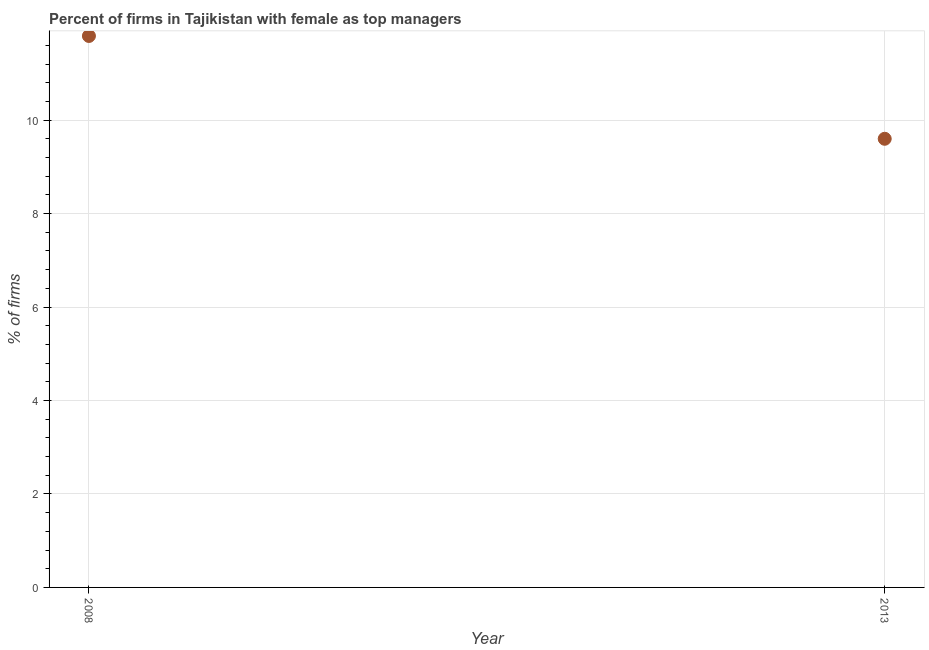Across all years, what is the minimum percentage of firms with female as top manager?
Your answer should be very brief. 9.6. What is the sum of the percentage of firms with female as top manager?
Your response must be concise. 21.4. What is the difference between the percentage of firms with female as top manager in 2008 and 2013?
Make the answer very short. 2.2. What is the median percentage of firms with female as top manager?
Offer a terse response. 10.7. What is the ratio of the percentage of firms with female as top manager in 2008 to that in 2013?
Your response must be concise. 1.23. Does the percentage of firms with female as top manager monotonically increase over the years?
Offer a very short reply. No. How many dotlines are there?
Keep it short and to the point. 1. How many years are there in the graph?
Your answer should be compact. 2. Are the values on the major ticks of Y-axis written in scientific E-notation?
Give a very brief answer. No. Does the graph contain any zero values?
Offer a very short reply. No. Does the graph contain grids?
Provide a short and direct response. Yes. What is the title of the graph?
Ensure brevity in your answer.  Percent of firms in Tajikistan with female as top managers. What is the label or title of the X-axis?
Your answer should be compact. Year. What is the label or title of the Y-axis?
Your response must be concise. % of firms. What is the % of firms in 2013?
Offer a very short reply. 9.6. What is the difference between the % of firms in 2008 and 2013?
Provide a short and direct response. 2.2. What is the ratio of the % of firms in 2008 to that in 2013?
Provide a short and direct response. 1.23. 